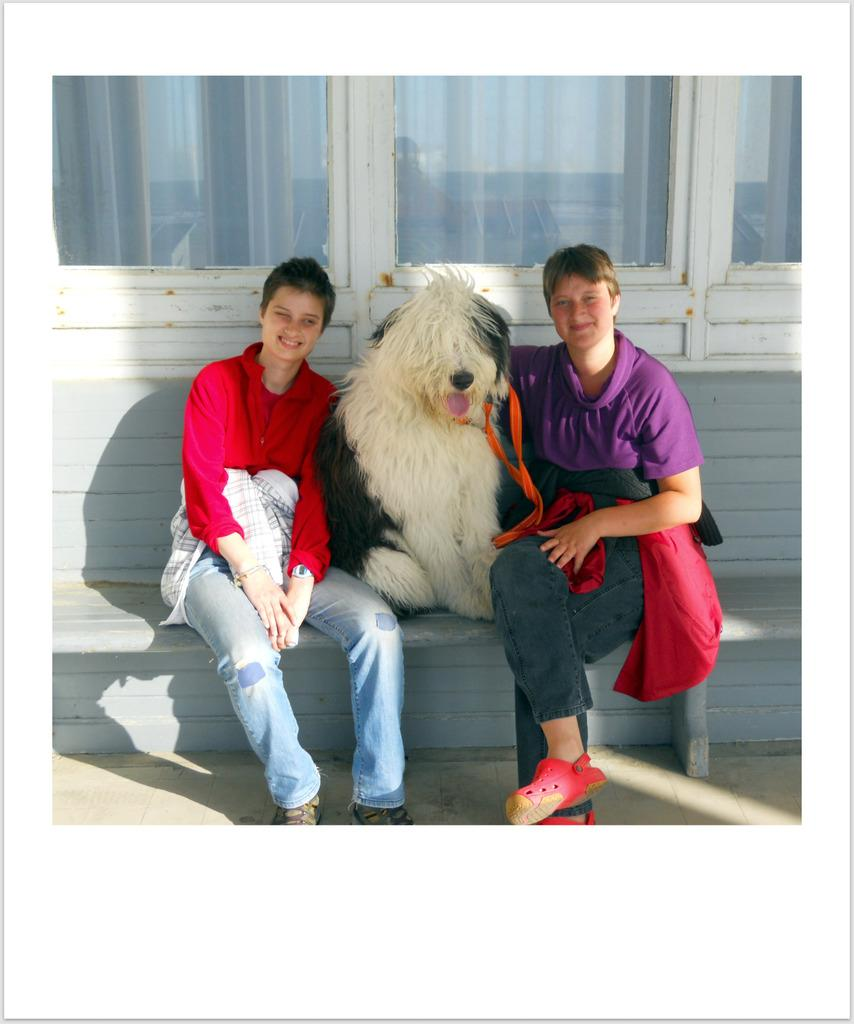How many people are in the image? There are two women in the image. What other living creature is present in the image? A dog is present in the image. How are the women positioned in relation to the dog? The women are positioned on either side of the dog. What type of clouds can be seen in the image? There are no clouds present in the image; it features two women and a dog. How many children are visible in the image? There are no children present in the image; it features two women and a dog. 